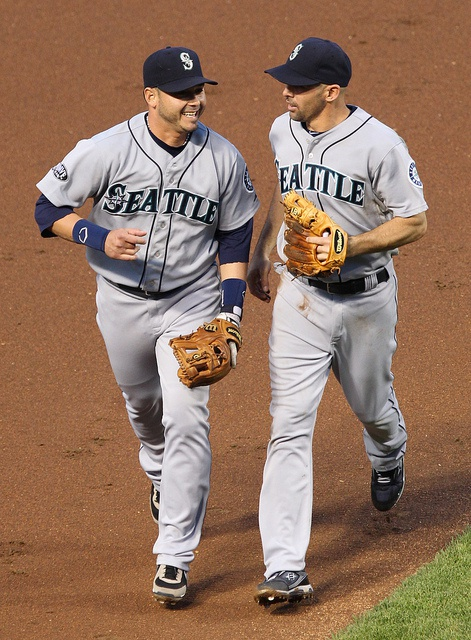Describe the objects in this image and their specific colors. I can see people in brown, lightgray, darkgray, black, and gray tones, people in brown, lightgray, darkgray, black, and gray tones, baseball glove in brown, orange, tan, and maroon tones, and baseball glove in brown, tan, maroon, and black tones in this image. 